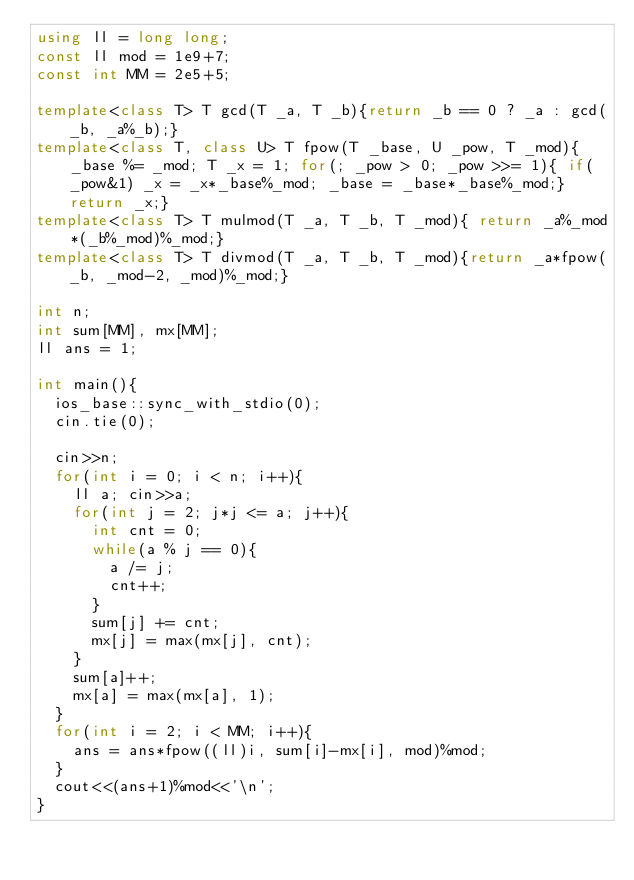Convert code to text. <code><loc_0><loc_0><loc_500><loc_500><_C++_>using ll = long long;
const ll mod = 1e9+7;
const int MM = 2e5+5;

template<class T> T gcd(T _a, T _b){return _b == 0 ? _a : gcd(_b, _a%_b);}
template<class T, class U> T fpow(T _base, U _pow, T _mod){_base %= _mod; T _x = 1; for(; _pow > 0; _pow >>= 1){ if(_pow&1) _x = _x*_base%_mod; _base = _base*_base%_mod;} return _x;}
template<class T> T mulmod(T _a, T _b, T _mod){ return _a%_mod*(_b%_mod)%_mod;}
template<class T> T divmod(T _a, T _b, T _mod){return _a*fpow(_b, _mod-2, _mod)%_mod;}

int n;
int sum[MM], mx[MM];
ll ans = 1;

int main(){
	ios_base::sync_with_stdio(0);
	cin.tie(0);
	
	cin>>n;
	for(int i = 0; i < n; i++){
		ll a; cin>>a;
		for(int j = 2; j*j <= a; j++){
			int cnt = 0;
			while(a % j == 0){
				a /= j;
				cnt++;
			}
			sum[j] += cnt;
			mx[j] = max(mx[j], cnt);
		}
		sum[a]++;
		mx[a] = max(mx[a], 1);
	}
	for(int i = 2; i < MM; i++){
		ans = ans*fpow((ll)i, sum[i]-mx[i], mod)%mod;
	}
	cout<<(ans+1)%mod<<'\n';
}</code> 